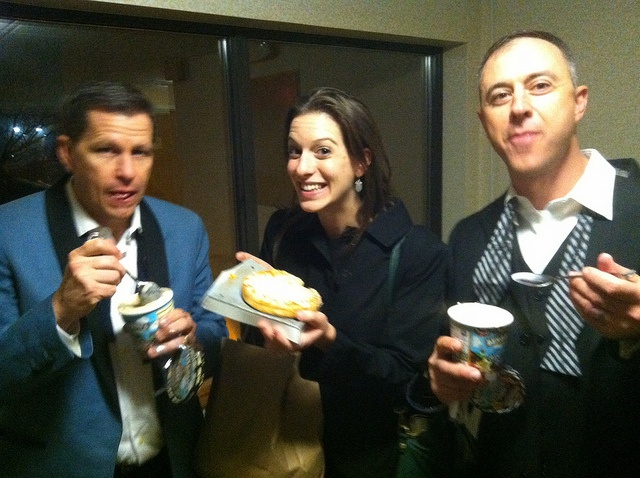Describe the objects in this image and their specific colors. I can see people in black, ivory, gray, and tan tones, people in black, blue, teal, and maroon tones, people in black, maroon, tan, and beige tones, tie in black, gray, darkgray, and purple tones, and cup in black, white, gray, and darkgreen tones in this image. 